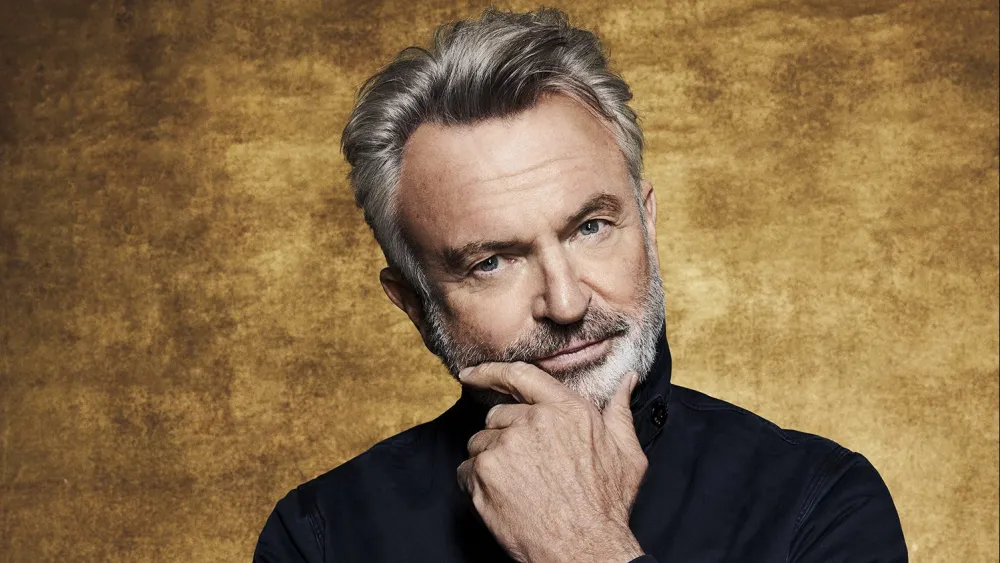What story can you imagine from this portrait? In this portrait, I imagine the story of a renowned writer who has spent years capturing the complexities of human emotions and experiences in his novels. The gold background symbolizes the accolades and recognition he has received throughout his career. The thoughtful pose reflects his process of contemplating the themes and characters for his next groundbreaking novel. Dressed in a simple yet elegant black shirt, he embodies the essence of a creative genius at work. His slight smile suggests he has just had a breakthrough idea, one that will soon transform into a masterpiece that resonates deeply with readers around the world. What is the subject thinking about in this moment? In this moment, the subject might be reflecting on his journey, considering both the challenges and triumphs that have shaped him. He could be thinking about an important lesson he has learned recently, or a cherished memory that brings him a sense of nostalgia. Alternatively, he might be weighing a significant decision, such as embarking on a new project, reconnecting with a long-lost friend, or exploring a new passion. His thoughtful demeanor suggests that whatever he is thinking about, it holds deep personal significance and could potentially influence his future path. If the gold background were a portal to another world, what kind of world would it lead to? If the gold background were a portal to another world, it would lead to a fantastical realm filled with wonder and magic. This world would be bathed in golden light, where the skies shimmer with hues of sunrise and sunset. Majestic golden trees with leaves that sparkle like jewels line the paths, and rivers flow with liquid gold. In this realm, wisdom and creativity reign supreme; the inhabitants are enlightened beings who create art, music, and literature that transcend the ordinary. It’s a utopia where thoughts become reality, and every being is in harmonious contemplation and creation, fostering a society built on understanding and insight. 